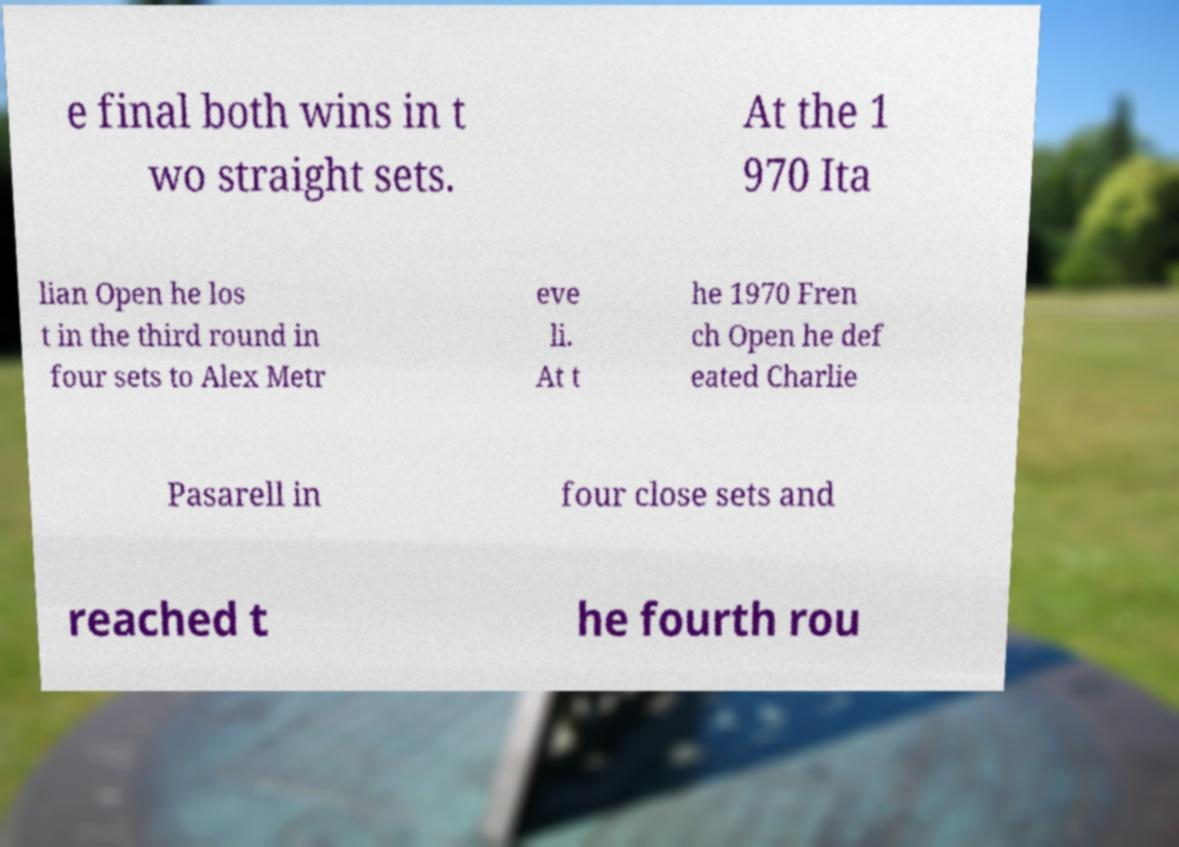Can you accurately transcribe the text from the provided image for me? e final both wins in t wo straight sets. At the 1 970 Ita lian Open he los t in the third round in four sets to Alex Metr eve li. At t he 1970 Fren ch Open he def eated Charlie Pasarell in four close sets and reached t he fourth rou 